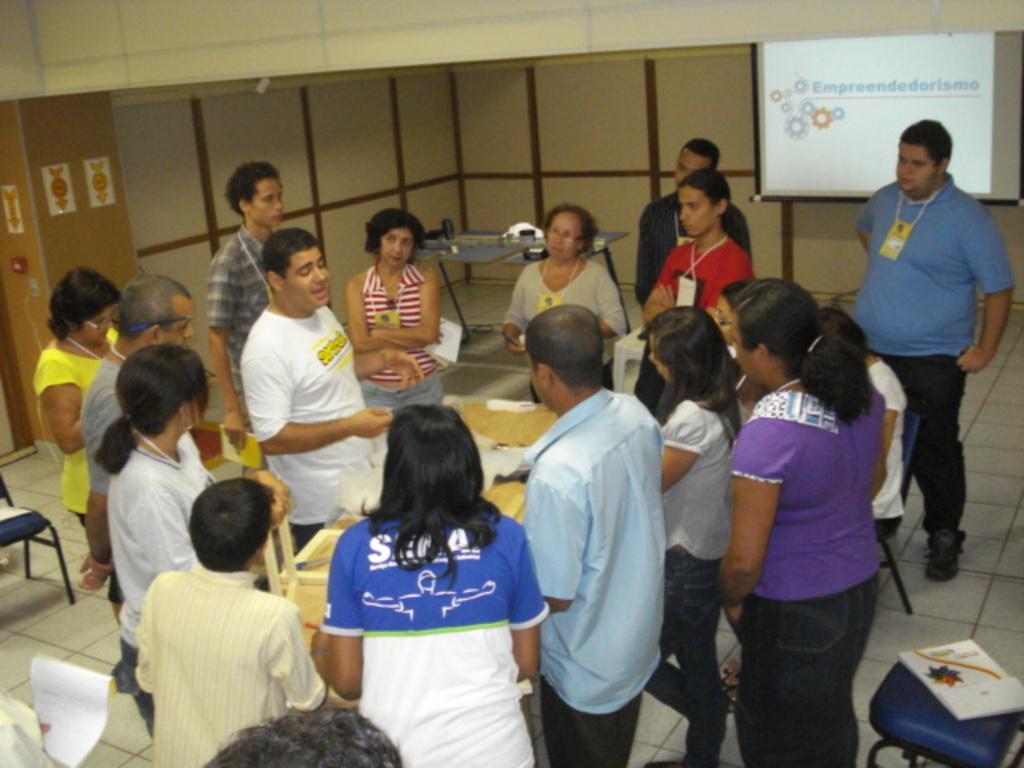In one or two sentences, can you explain what this image depicts? In this picture I can see some people are standing in front of the table, on which we can see some objects, behind we can see screen on the board and also we can see some chairs. 